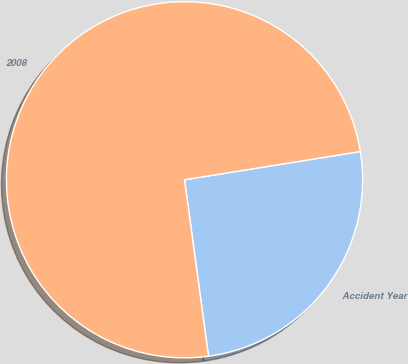<chart> <loc_0><loc_0><loc_500><loc_500><pie_chart><fcel>Accident Year<fcel>2008<nl><fcel>25.38%<fcel>74.62%<nl></chart> 